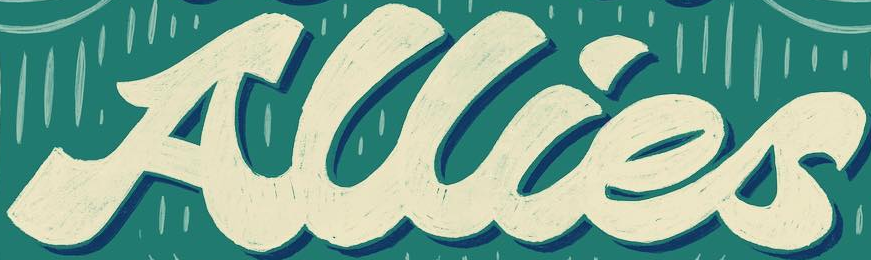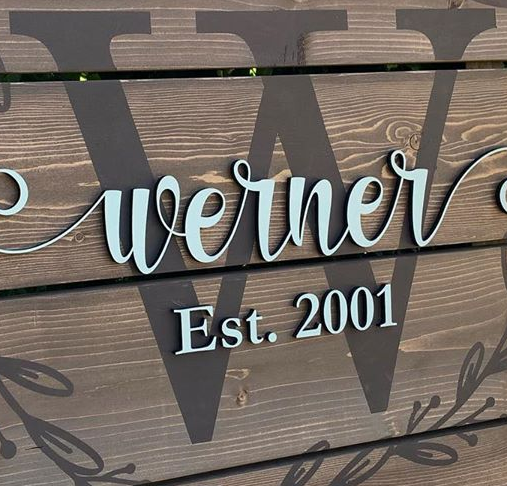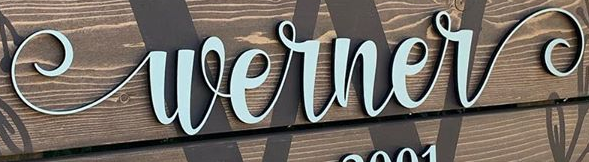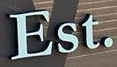What text appears in these images from left to right, separated by a semicolon? Allies; W; Werner; Est. 